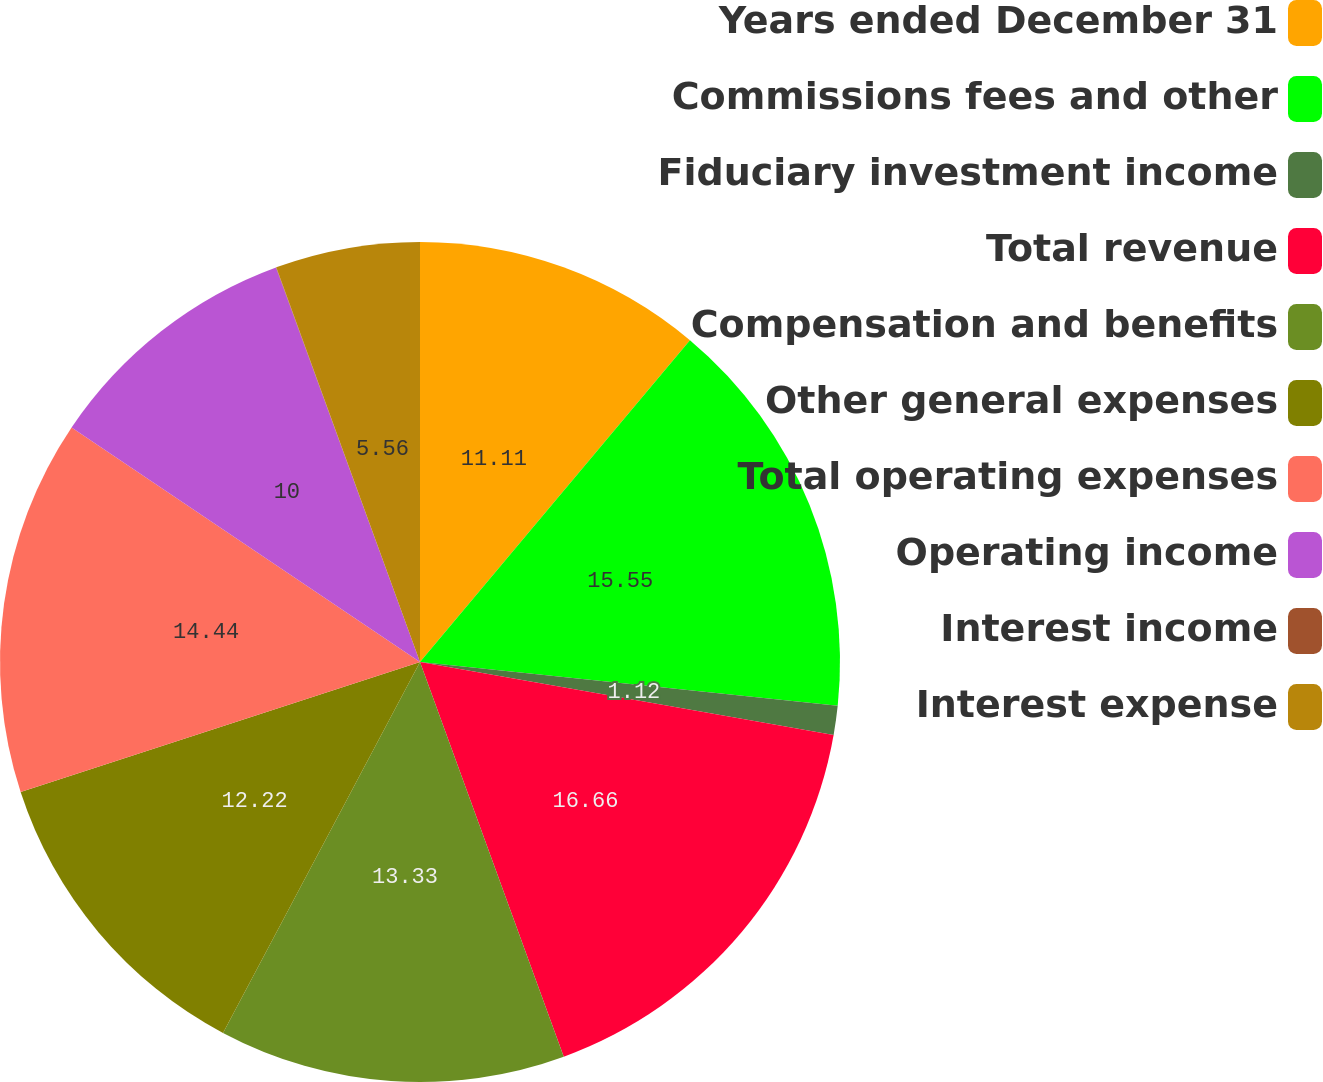<chart> <loc_0><loc_0><loc_500><loc_500><pie_chart><fcel>Years ended December 31<fcel>Commissions fees and other<fcel>Fiduciary investment income<fcel>Total revenue<fcel>Compensation and benefits<fcel>Other general expenses<fcel>Total operating expenses<fcel>Operating income<fcel>Interest income<fcel>Interest expense<nl><fcel>11.11%<fcel>15.55%<fcel>1.12%<fcel>16.66%<fcel>13.33%<fcel>12.22%<fcel>14.44%<fcel>10.0%<fcel>0.01%<fcel>5.56%<nl></chart> 